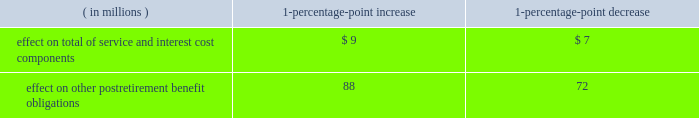Marathon oil corporation notes to consolidated financial statements assumed health care cost trend rates have a significant effect on the amounts reported for defined benefit retiree health care plans .
A one-percentage-point change in assumed health care cost trend rates would have the following effects : ( in millions ) 1-percentage- point increase 1-percentage- point decrease .
Plan investment policies and strategies the investment policies for our u.s .
And international pension plan assets reflect the funded status of the plans and expectations regarding our future ability to make further contributions .
Long-term investment goals are to : ( 1 ) manage the assets in accordance with the legal requirements of all applicable laws ; ( 2 ) produce investment returns which meet or exceed the rates of return achievable in the capital markets while maintaining the risk parameters set by the plans 2019 investment committees and protecting the assets from any erosion of purchasing power ; and ( 3 ) position the portfolios with a long-term risk/return orientation .
U.s .
Plans 2013 historical performance and future expectations suggest that common stocks will provide higher total investment returns than fixed income securities over a long-term investment horizon .
Short-term investments only reflect the liquidity requirements for making pension payments .
As such , the plans 2019 targeted asset allocation is comprised of 75 percent equity securities and 25 percent fixed income securities .
In the second quarter of 2009 , we exchanged the majority of our publicly-traded stocks and bonds for interests in pooled equity and fixed income investment funds from our outside manager , representing 58 percent and 20 percent of u.s .
Plan assets , respectively , as of december 31 , 2009 .
These funds are managed with the same style and strategy as when the securities were held separately .
Each fund 2019s main objective is to provide investors with exposure to either a publicly-traded equity or fixed income portfolio comprised of both u.s .
And non-u.s .
Securities .
The equity fund holdings primarily consist of publicly-traded individually-held securities in various sectors of many industries .
The fixed income fund holdings primarily consist of publicly-traded investment-grade bonds .
The plans 2019 assets are managed by a third-party investment manager .
The investment manager has limited discretion to move away from the target allocations based upon the manager 2019s judgment as to current confidence or concern regarding the capital markets .
Investments are diversified by industry and type , limited by grade and maturity .
The plans 2019 investment policy prohibits investments in any securities in the steel industry and allows derivatives subject to strict guidelines , such that derivatives may only be written against equity securities in the portfolio .
Investment performance and risk is measured and monitored on an ongoing basis through quarterly investment meetings and periodic asset and liability studies .
International plans 2013 our international plans 2019 target asset allocation is comprised of 70 percent equity securities and 30 percent fixed income securities .
The plan assets are invested in six separate portfolios , mainly pooled fund vehicles , managed by several professional investment managers .
Investments are diversified by industry and type , limited by grade and maturity .
The use of derivatives by the investment managers is permitted , subject to strict guidelines .
The investment managers 2019 performance is measured independently by a third-party asset servicing consulting firm .
Overall , investment performance and risk is measured and monitored on an ongoing basis through quarterly investment portfolio reviews and periodic asset and liability studies .
Fair value measurements plan assets are measured at fair value .
The definition and approaches to measuring fair value and the three levels of the fair value hierarchy are described in note 16 .
The following provides a description of the valuation techniques employed for each major plan asset category at december 31 , 2009 and 2008 .
Cash and cash equivalents 2013 cash and cash equivalents include cash on deposit and an investment in a money market mutual fund that invests mainly in short-term instruments and cash , both of which are valued using a .
What would the effect on other postretirement benefit obligations be if there was a 2-percent point decrease? 
Computations: (72 * 2)
Answer: 144.0. 